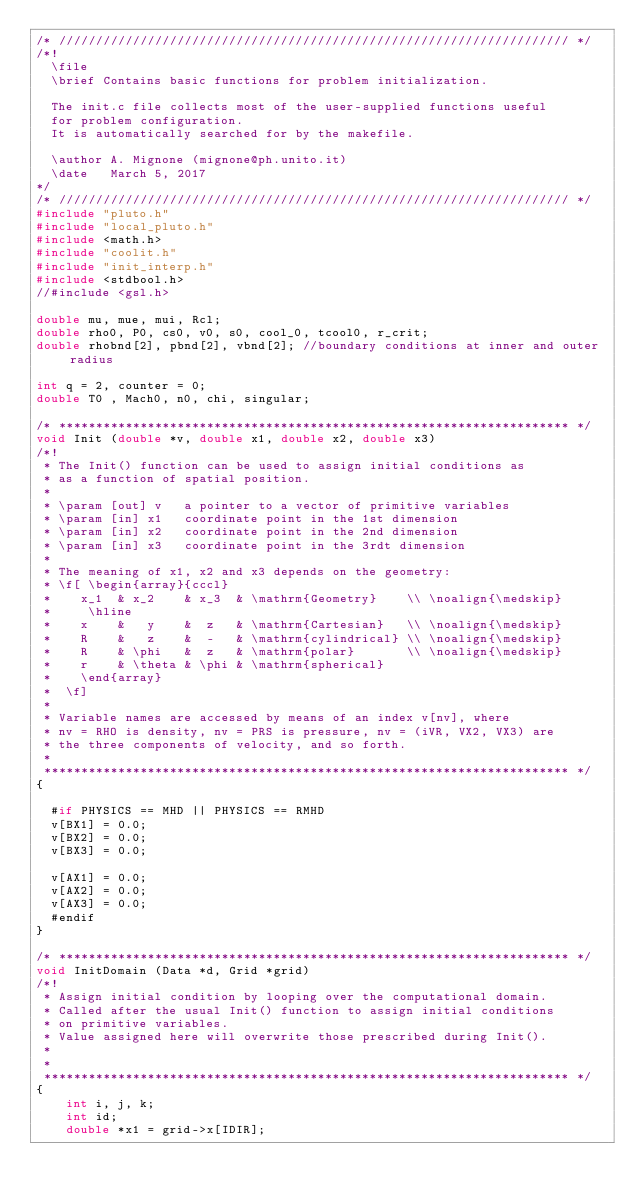<code> <loc_0><loc_0><loc_500><loc_500><_C_>/* ///////////////////////////////////////////////////////////////////// */
/*! 
  \file  
  \brief Contains basic functions for problem initialization.

  The init.c file collects most of the user-supplied functions useful 
  for problem configuration.
  It is automatically searched for by the makefile.

  \author A. Mignone (mignone@ph.unito.it)
  \date   March 5, 2017
*/
/* ///////////////////////////////////////////////////////////////////// */
#include "pluto.h"
#include "local_pluto.h"
#include <math.h>
#include "coolit.h"
#include "init_interp.h"
#include <stdbool.h>
//#include <gsl.h>

double mu, mue, mui, Rcl;
double rho0, P0, cs0, v0, s0, cool_0, tcool0, r_crit;
double rhobnd[2], pbnd[2], vbnd[2]; //boundary conditions at inner and outer radius
  
int q = 2, counter = 0;
double T0 , Mach0, n0, chi, singular;

/* ********************************************************************* */
void Init (double *v, double x1, double x2, double x3)
/*! 
 * The Init() function can be used to assign initial conditions as
 * as a function of spatial position.
 *
 * \param [out] v   a pointer to a vector of primitive variables
 * \param [in] x1   coordinate point in the 1st dimension
 * \param [in] x2   coordinate point in the 2nd dimension
 * \param [in] x3   coordinate point in the 3rdt dimension
 *
 * The meaning of x1, x2 and x3 depends on the geometry:
 * \f[ \begin{array}{cccl}
 *    x_1  & x_2    & x_3  & \mathrm{Geometry}    \\ \noalign{\medskip}
 *     \hline
 *    x    &   y    &  z   & \mathrm{Cartesian}   \\ \noalign{\medskip}
 *    R    &   z    &  -   & \mathrm{cylindrical} \\ \noalign{\medskip}
 *    R    & \phi   &  z   & \mathrm{polar}       \\ \noalign{\medskip}
 *    r    & \theta & \phi & \mathrm{spherical} 
 *    \end{array}
 *  \f]
 *
 * Variable names are accessed by means of an index v[nv], where
 * nv = RHO is density, nv = PRS is pressure, nv = (iVR, VX2, VX3) are
 * the three components of velocity, and so forth.
 *
 *********************************************************************** */
{

  #if PHYSICS == MHD || PHYSICS == RMHD
  v[BX1] = 0.0;
  v[BX2] = 0.0;
  v[BX3] = 0.0;

  v[AX1] = 0.0;
  v[AX2] = 0.0;
  v[AX3] = 0.0;
  #endif
}

/* ********************************************************************* */
void InitDomain (Data *d, Grid *grid)
/*! 
 * Assign initial condition by looping over the computational domain.
 * Called after the usual Init() function to assign initial conditions
 * on primitive variables.
 * Value assigned here will overwrite those prescribed during Init().
 *
 *
 *********************************************************************** */
{
	int i, j, k; 
	int id; 
	double *x1 = grid->x[IDIR]; </code> 